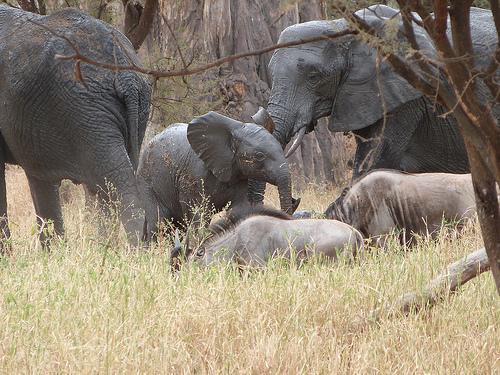How many elephants are there?
Give a very brief answer. 3. 